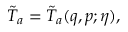<formula> <loc_0><loc_0><loc_500><loc_500>\tilde { T } _ { a } = \tilde { T } _ { a } ( q , p ; \eta ) ,</formula> 